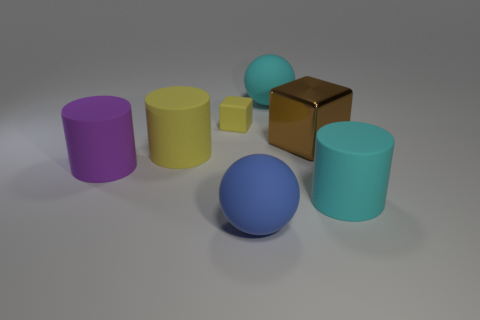The yellow block that is the same material as the yellow cylinder is what size?
Keep it short and to the point. Small. Do the yellow cylinder and the large blue thing have the same material?
Provide a short and direct response. Yes. There is a big ball behind the block to the right of the big thing that is in front of the cyan cylinder; what is its color?
Your response must be concise. Cyan. What shape is the blue rubber thing?
Keep it short and to the point. Sphere. There is a small matte thing; does it have the same color as the rubber cylinder behind the purple matte object?
Keep it short and to the point. Yes. Is the number of large metal objects that are to the right of the metal object the same as the number of brown cylinders?
Ensure brevity in your answer.  Yes. How many other purple things have the same size as the purple thing?
Offer a terse response. 0. What shape is the other rubber thing that is the same color as the tiny rubber object?
Give a very brief answer. Cylinder. Is there a blue matte object?
Give a very brief answer. Yes. There is a cyan thing in front of the brown shiny block; is it the same shape as the small yellow thing behind the big yellow rubber cylinder?
Offer a terse response. No. 